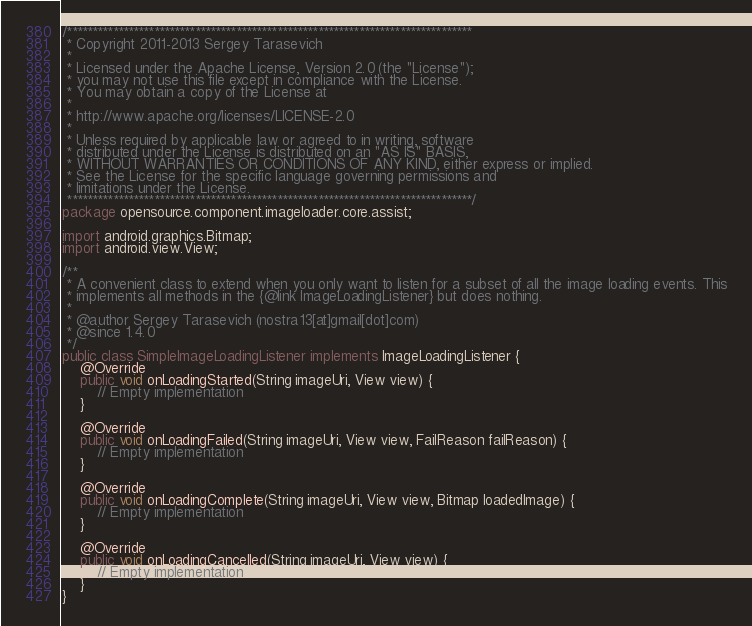Convert code to text. <code><loc_0><loc_0><loc_500><loc_500><_Java_>/*******************************************************************************
 * Copyright 2011-2013 Sergey Tarasevich
 *
 * Licensed under the Apache License, Version 2.0 (the "License");
 * you may not use this file except in compliance with the License.
 * You may obtain a copy of the License at
 *
 * http://www.apache.org/licenses/LICENSE-2.0
 *
 * Unless required by applicable law or agreed to in writing, software
 * distributed under the License is distributed on an "AS IS" BASIS,
 * WITHOUT WARRANTIES OR CONDITIONS OF ANY KIND, either express or implied.
 * See the License for the specific language governing permissions and
 * limitations under the License.
 *******************************************************************************/
package opensource.component.imageloader.core.assist;

import android.graphics.Bitmap;
import android.view.View;

/**
 * A convenient class to extend when you only want to listen for a subset of all the image loading events. This
 * implements all methods in the {@link ImageLoadingListener} but does nothing.
 *
 * @author Sergey Tarasevich (nostra13[at]gmail[dot]com)
 * @since 1.4.0
 */
public class SimpleImageLoadingListener implements ImageLoadingListener {
	@Override
	public void onLoadingStarted(String imageUri, View view) {
		// Empty implementation
	}

	@Override
	public void onLoadingFailed(String imageUri, View view, FailReason failReason) {
		// Empty implementation
	}

	@Override
	public void onLoadingComplete(String imageUri, View view, Bitmap loadedImage) {
		// Empty implementation
	}

	@Override
	public void onLoadingCancelled(String imageUri, View view) {
		// Empty implementation
	}
}
</code> 